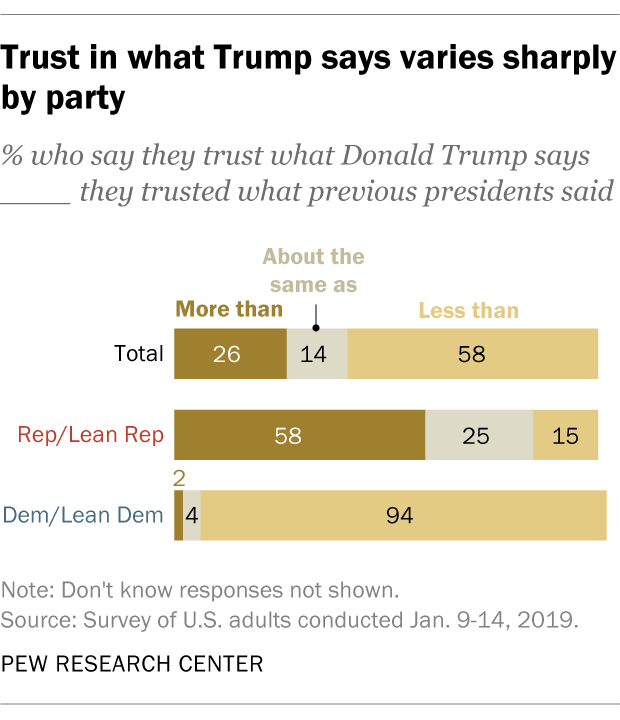Highlight a few significant elements in this photo. The median of the grey bars is less than the median of the dark brown bars. In the graph of values from 0.02 to 1, the smallest value can be found. 